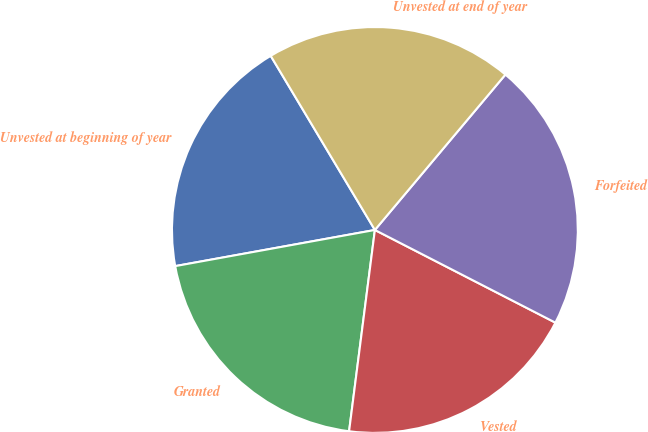Convert chart. <chart><loc_0><loc_0><loc_500><loc_500><pie_chart><fcel>Unvested at beginning of year<fcel>Granted<fcel>Vested<fcel>Forfeited<fcel>Unvested at end of year<nl><fcel>19.27%<fcel>20.12%<fcel>19.48%<fcel>21.43%<fcel>19.7%<nl></chart> 